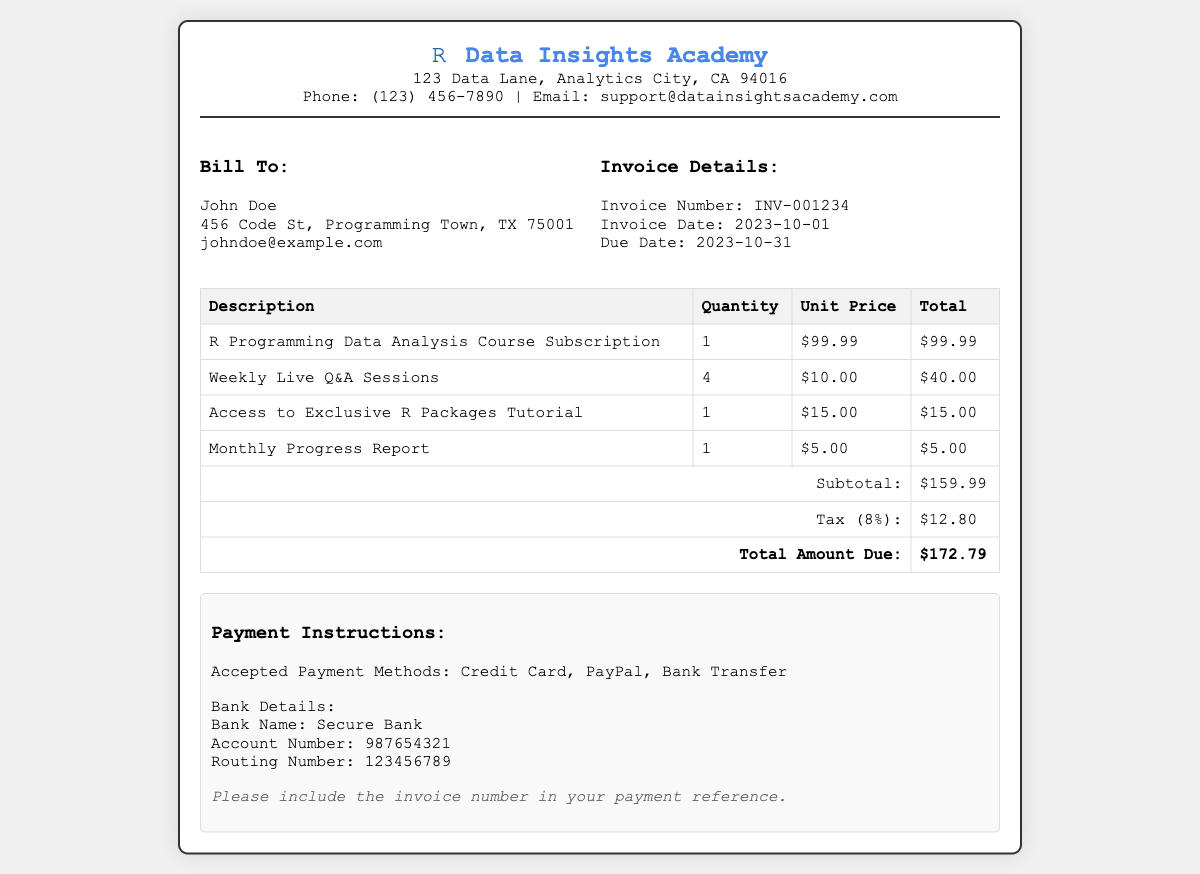What is the invoice number? The invoice number is clearly stated in the invoice details section.
Answer: INV-001234 What is the subtotal amount? The subtotal amount can be found at the bottom of the itemized list before taxes.
Answer: $159.99 Who is the billing recipient? The billing recipient's name is mentioned in the "Bill To" section of the document.
Answer: John Doe What is the due date for payment? The due date is specified in the invoice details section.
Answer: 2023-10-31 How many live Q&A sessions are included? The quantity of live Q&A sessions is indicated in the itemized services table.
Answer: 4 What is the tax rate applied? The tax rate is noted next to the tax line in the invoice.
Answer: 8% What payment methods are accepted? The accepted payment methods are listed clearly under payment instructions.
Answer: Credit Card, PayPal, Bank Transfer What is the total amount due? The total amount due is prominently displayed at the bottom of the itemized list.
Answer: $172.79 What is included in the monthly report service? The service description can be found in the itemized table under Monthly Progress Report.
Answer: Monthly Progress Report 